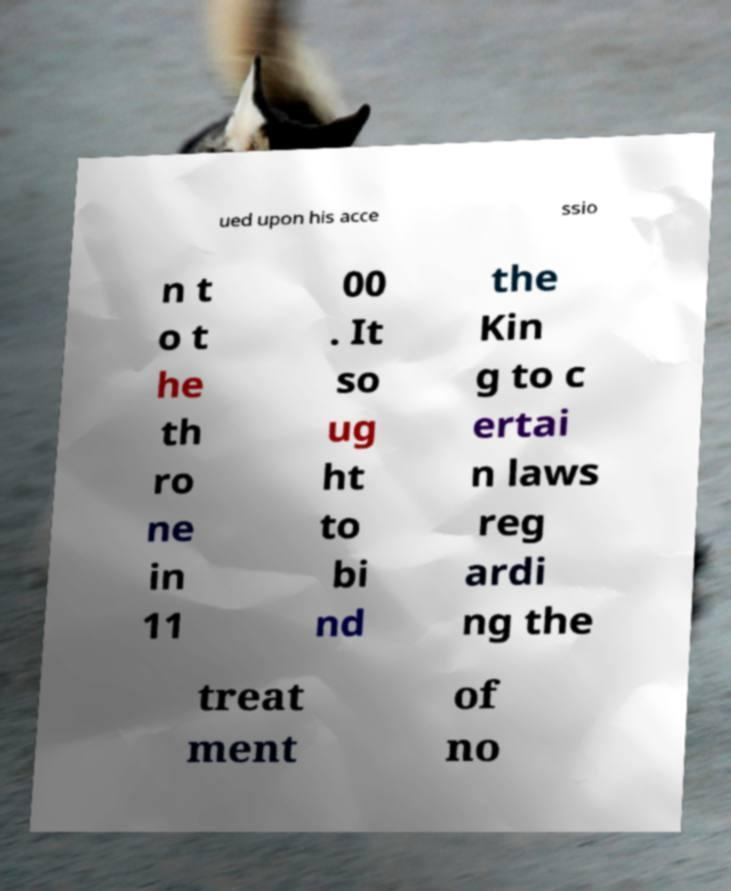I need the written content from this picture converted into text. Can you do that? ued upon his acce ssio n t o t he th ro ne in 11 00 . It so ug ht to bi nd the Kin g to c ertai n laws reg ardi ng the treat ment of no 